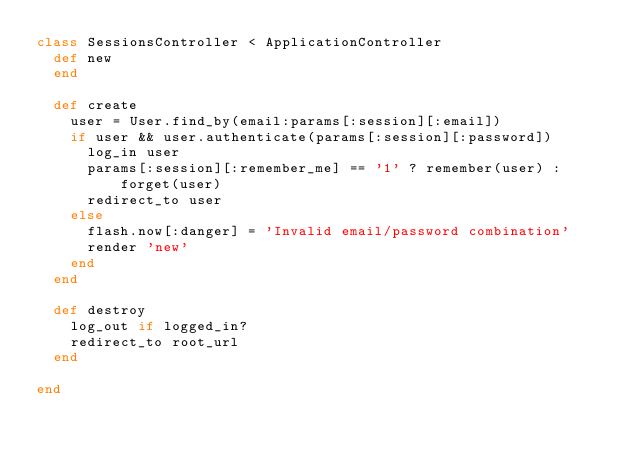<code> <loc_0><loc_0><loc_500><loc_500><_Ruby_>class SessionsController < ApplicationController
  def new
  end

  def create
    user = User.find_by(email:params[:session][:email])
    if user && user.authenticate(params[:session][:password])
      log_in user
      params[:session][:remember_me] == '1' ? remember(user) : forget(user)
      redirect_to user
    else
      flash.now[:danger] = 'Invalid email/password combination'
      render 'new'
    end
  end

  def destroy
    log_out if logged_in?
    redirect_to root_url
  end

end
</code> 